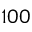Convert formula to latex. <formula><loc_0><loc_0><loc_500><loc_500>1 0 0</formula> 